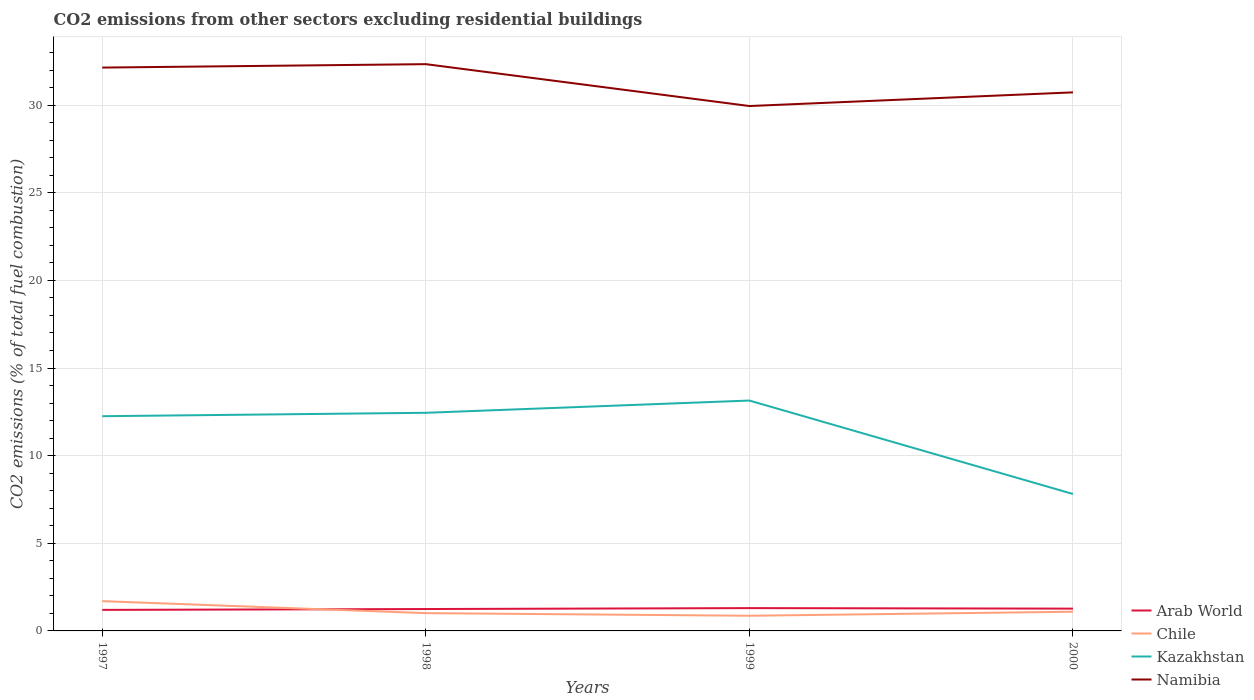Does the line corresponding to Arab World intersect with the line corresponding to Namibia?
Offer a terse response. No. Is the number of lines equal to the number of legend labels?
Ensure brevity in your answer.  Yes. Across all years, what is the maximum total CO2 emitted in Kazakhstan?
Make the answer very short. 7.81. In which year was the total CO2 emitted in Namibia maximum?
Your answer should be very brief. 1999. What is the total total CO2 emitted in Namibia in the graph?
Keep it short and to the point. 1.61. What is the difference between the highest and the second highest total CO2 emitted in Arab World?
Keep it short and to the point. 0.1. How many lines are there?
Provide a short and direct response. 4. What is the difference between two consecutive major ticks on the Y-axis?
Offer a terse response. 5. Are the values on the major ticks of Y-axis written in scientific E-notation?
Offer a terse response. No. Does the graph contain any zero values?
Give a very brief answer. No. How many legend labels are there?
Provide a succinct answer. 4. How are the legend labels stacked?
Provide a succinct answer. Vertical. What is the title of the graph?
Offer a terse response. CO2 emissions from other sectors excluding residential buildings. Does "Puerto Rico" appear as one of the legend labels in the graph?
Offer a very short reply. No. What is the label or title of the Y-axis?
Keep it short and to the point. CO2 emissions (% of total fuel combustion). What is the CO2 emissions (% of total fuel combustion) in Arab World in 1997?
Provide a short and direct response. 1.2. What is the CO2 emissions (% of total fuel combustion) of Chile in 1997?
Provide a succinct answer. 1.7. What is the CO2 emissions (% of total fuel combustion) in Kazakhstan in 1997?
Your answer should be compact. 12.25. What is the CO2 emissions (% of total fuel combustion) in Namibia in 1997?
Offer a terse response. 32.14. What is the CO2 emissions (% of total fuel combustion) of Arab World in 1998?
Keep it short and to the point. 1.25. What is the CO2 emissions (% of total fuel combustion) of Chile in 1998?
Keep it short and to the point. 1.01. What is the CO2 emissions (% of total fuel combustion) in Kazakhstan in 1998?
Provide a short and direct response. 12.45. What is the CO2 emissions (% of total fuel combustion) in Namibia in 1998?
Provide a short and direct response. 32.34. What is the CO2 emissions (% of total fuel combustion) of Arab World in 1999?
Provide a succinct answer. 1.3. What is the CO2 emissions (% of total fuel combustion) of Chile in 1999?
Your answer should be very brief. 0.87. What is the CO2 emissions (% of total fuel combustion) of Kazakhstan in 1999?
Provide a short and direct response. 13.14. What is the CO2 emissions (% of total fuel combustion) of Namibia in 1999?
Keep it short and to the point. 29.95. What is the CO2 emissions (% of total fuel combustion) in Arab World in 2000?
Keep it short and to the point. 1.27. What is the CO2 emissions (% of total fuel combustion) in Chile in 2000?
Give a very brief answer. 1.09. What is the CO2 emissions (% of total fuel combustion) of Kazakhstan in 2000?
Ensure brevity in your answer.  7.81. What is the CO2 emissions (% of total fuel combustion) of Namibia in 2000?
Ensure brevity in your answer.  30.73. Across all years, what is the maximum CO2 emissions (% of total fuel combustion) in Arab World?
Offer a very short reply. 1.3. Across all years, what is the maximum CO2 emissions (% of total fuel combustion) of Chile?
Give a very brief answer. 1.7. Across all years, what is the maximum CO2 emissions (% of total fuel combustion) in Kazakhstan?
Your answer should be very brief. 13.14. Across all years, what is the maximum CO2 emissions (% of total fuel combustion) of Namibia?
Ensure brevity in your answer.  32.34. Across all years, what is the minimum CO2 emissions (% of total fuel combustion) of Arab World?
Provide a short and direct response. 1.2. Across all years, what is the minimum CO2 emissions (% of total fuel combustion) of Chile?
Your answer should be very brief. 0.87. Across all years, what is the minimum CO2 emissions (% of total fuel combustion) of Kazakhstan?
Your answer should be very brief. 7.81. Across all years, what is the minimum CO2 emissions (% of total fuel combustion) in Namibia?
Make the answer very short. 29.95. What is the total CO2 emissions (% of total fuel combustion) in Arab World in the graph?
Offer a very short reply. 5.02. What is the total CO2 emissions (% of total fuel combustion) of Chile in the graph?
Your answer should be very brief. 4.67. What is the total CO2 emissions (% of total fuel combustion) in Kazakhstan in the graph?
Ensure brevity in your answer.  45.66. What is the total CO2 emissions (% of total fuel combustion) in Namibia in the graph?
Offer a very short reply. 125.16. What is the difference between the CO2 emissions (% of total fuel combustion) in Arab World in 1997 and that in 1998?
Make the answer very short. -0.05. What is the difference between the CO2 emissions (% of total fuel combustion) of Chile in 1997 and that in 1998?
Keep it short and to the point. 0.68. What is the difference between the CO2 emissions (% of total fuel combustion) in Kazakhstan in 1997 and that in 1998?
Provide a succinct answer. -0.19. What is the difference between the CO2 emissions (% of total fuel combustion) of Namibia in 1997 and that in 1998?
Offer a terse response. -0.2. What is the difference between the CO2 emissions (% of total fuel combustion) of Arab World in 1997 and that in 1999?
Make the answer very short. -0.1. What is the difference between the CO2 emissions (% of total fuel combustion) in Chile in 1997 and that in 1999?
Ensure brevity in your answer.  0.83. What is the difference between the CO2 emissions (% of total fuel combustion) in Kazakhstan in 1997 and that in 1999?
Offer a terse response. -0.89. What is the difference between the CO2 emissions (% of total fuel combustion) of Namibia in 1997 and that in 1999?
Provide a succinct answer. 2.19. What is the difference between the CO2 emissions (% of total fuel combustion) of Arab World in 1997 and that in 2000?
Your answer should be very brief. -0.07. What is the difference between the CO2 emissions (% of total fuel combustion) in Chile in 1997 and that in 2000?
Keep it short and to the point. 0.6. What is the difference between the CO2 emissions (% of total fuel combustion) of Kazakhstan in 1997 and that in 2000?
Keep it short and to the point. 4.44. What is the difference between the CO2 emissions (% of total fuel combustion) in Namibia in 1997 and that in 2000?
Offer a terse response. 1.41. What is the difference between the CO2 emissions (% of total fuel combustion) of Arab World in 1998 and that in 1999?
Your answer should be compact. -0.05. What is the difference between the CO2 emissions (% of total fuel combustion) of Chile in 1998 and that in 1999?
Your answer should be compact. 0.15. What is the difference between the CO2 emissions (% of total fuel combustion) of Kazakhstan in 1998 and that in 1999?
Offer a terse response. -0.7. What is the difference between the CO2 emissions (% of total fuel combustion) in Namibia in 1998 and that in 1999?
Offer a terse response. 2.39. What is the difference between the CO2 emissions (% of total fuel combustion) in Arab World in 1998 and that in 2000?
Offer a terse response. -0.02. What is the difference between the CO2 emissions (% of total fuel combustion) in Chile in 1998 and that in 2000?
Give a very brief answer. -0.08. What is the difference between the CO2 emissions (% of total fuel combustion) of Kazakhstan in 1998 and that in 2000?
Provide a short and direct response. 4.63. What is the difference between the CO2 emissions (% of total fuel combustion) of Namibia in 1998 and that in 2000?
Keep it short and to the point. 1.61. What is the difference between the CO2 emissions (% of total fuel combustion) of Arab World in 1999 and that in 2000?
Give a very brief answer. 0.03. What is the difference between the CO2 emissions (% of total fuel combustion) in Chile in 1999 and that in 2000?
Your answer should be very brief. -0.23. What is the difference between the CO2 emissions (% of total fuel combustion) in Kazakhstan in 1999 and that in 2000?
Make the answer very short. 5.33. What is the difference between the CO2 emissions (% of total fuel combustion) in Namibia in 1999 and that in 2000?
Give a very brief answer. -0.78. What is the difference between the CO2 emissions (% of total fuel combustion) of Arab World in 1997 and the CO2 emissions (% of total fuel combustion) of Chile in 1998?
Provide a succinct answer. 0.19. What is the difference between the CO2 emissions (% of total fuel combustion) in Arab World in 1997 and the CO2 emissions (% of total fuel combustion) in Kazakhstan in 1998?
Give a very brief answer. -11.25. What is the difference between the CO2 emissions (% of total fuel combustion) in Arab World in 1997 and the CO2 emissions (% of total fuel combustion) in Namibia in 1998?
Your answer should be compact. -31.14. What is the difference between the CO2 emissions (% of total fuel combustion) in Chile in 1997 and the CO2 emissions (% of total fuel combustion) in Kazakhstan in 1998?
Your answer should be very brief. -10.75. What is the difference between the CO2 emissions (% of total fuel combustion) in Chile in 1997 and the CO2 emissions (% of total fuel combustion) in Namibia in 1998?
Provide a succinct answer. -30.64. What is the difference between the CO2 emissions (% of total fuel combustion) in Kazakhstan in 1997 and the CO2 emissions (% of total fuel combustion) in Namibia in 1998?
Keep it short and to the point. -20.09. What is the difference between the CO2 emissions (% of total fuel combustion) of Arab World in 1997 and the CO2 emissions (% of total fuel combustion) of Chile in 1999?
Provide a short and direct response. 0.33. What is the difference between the CO2 emissions (% of total fuel combustion) in Arab World in 1997 and the CO2 emissions (% of total fuel combustion) in Kazakhstan in 1999?
Offer a terse response. -11.94. What is the difference between the CO2 emissions (% of total fuel combustion) of Arab World in 1997 and the CO2 emissions (% of total fuel combustion) of Namibia in 1999?
Provide a succinct answer. -28.75. What is the difference between the CO2 emissions (% of total fuel combustion) in Chile in 1997 and the CO2 emissions (% of total fuel combustion) in Kazakhstan in 1999?
Offer a very short reply. -11.45. What is the difference between the CO2 emissions (% of total fuel combustion) of Chile in 1997 and the CO2 emissions (% of total fuel combustion) of Namibia in 1999?
Provide a succinct answer. -28.25. What is the difference between the CO2 emissions (% of total fuel combustion) in Kazakhstan in 1997 and the CO2 emissions (% of total fuel combustion) in Namibia in 1999?
Give a very brief answer. -17.7. What is the difference between the CO2 emissions (% of total fuel combustion) of Arab World in 1997 and the CO2 emissions (% of total fuel combustion) of Chile in 2000?
Ensure brevity in your answer.  0.1. What is the difference between the CO2 emissions (% of total fuel combustion) of Arab World in 1997 and the CO2 emissions (% of total fuel combustion) of Kazakhstan in 2000?
Your response must be concise. -6.61. What is the difference between the CO2 emissions (% of total fuel combustion) of Arab World in 1997 and the CO2 emissions (% of total fuel combustion) of Namibia in 2000?
Ensure brevity in your answer.  -29.53. What is the difference between the CO2 emissions (% of total fuel combustion) in Chile in 1997 and the CO2 emissions (% of total fuel combustion) in Kazakhstan in 2000?
Offer a very short reply. -6.12. What is the difference between the CO2 emissions (% of total fuel combustion) of Chile in 1997 and the CO2 emissions (% of total fuel combustion) of Namibia in 2000?
Provide a short and direct response. -29.03. What is the difference between the CO2 emissions (% of total fuel combustion) of Kazakhstan in 1997 and the CO2 emissions (% of total fuel combustion) of Namibia in 2000?
Offer a terse response. -18.48. What is the difference between the CO2 emissions (% of total fuel combustion) of Arab World in 1998 and the CO2 emissions (% of total fuel combustion) of Chile in 1999?
Provide a succinct answer. 0.38. What is the difference between the CO2 emissions (% of total fuel combustion) in Arab World in 1998 and the CO2 emissions (% of total fuel combustion) in Kazakhstan in 1999?
Provide a succinct answer. -11.9. What is the difference between the CO2 emissions (% of total fuel combustion) of Arab World in 1998 and the CO2 emissions (% of total fuel combustion) of Namibia in 1999?
Ensure brevity in your answer.  -28.7. What is the difference between the CO2 emissions (% of total fuel combustion) of Chile in 1998 and the CO2 emissions (% of total fuel combustion) of Kazakhstan in 1999?
Your response must be concise. -12.13. What is the difference between the CO2 emissions (% of total fuel combustion) in Chile in 1998 and the CO2 emissions (% of total fuel combustion) in Namibia in 1999?
Ensure brevity in your answer.  -28.93. What is the difference between the CO2 emissions (% of total fuel combustion) of Kazakhstan in 1998 and the CO2 emissions (% of total fuel combustion) of Namibia in 1999?
Offer a very short reply. -17.5. What is the difference between the CO2 emissions (% of total fuel combustion) of Arab World in 1998 and the CO2 emissions (% of total fuel combustion) of Chile in 2000?
Give a very brief answer. 0.15. What is the difference between the CO2 emissions (% of total fuel combustion) of Arab World in 1998 and the CO2 emissions (% of total fuel combustion) of Kazakhstan in 2000?
Offer a terse response. -6.57. What is the difference between the CO2 emissions (% of total fuel combustion) in Arab World in 1998 and the CO2 emissions (% of total fuel combustion) in Namibia in 2000?
Keep it short and to the point. -29.48. What is the difference between the CO2 emissions (% of total fuel combustion) in Chile in 1998 and the CO2 emissions (% of total fuel combustion) in Kazakhstan in 2000?
Ensure brevity in your answer.  -6.8. What is the difference between the CO2 emissions (% of total fuel combustion) of Chile in 1998 and the CO2 emissions (% of total fuel combustion) of Namibia in 2000?
Make the answer very short. -29.71. What is the difference between the CO2 emissions (% of total fuel combustion) in Kazakhstan in 1998 and the CO2 emissions (% of total fuel combustion) in Namibia in 2000?
Keep it short and to the point. -18.28. What is the difference between the CO2 emissions (% of total fuel combustion) of Arab World in 1999 and the CO2 emissions (% of total fuel combustion) of Chile in 2000?
Provide a short and direct response. 0.21. What is the difference between the CO2 emissions (% of total fuel combustion) in Arab World in 1999 and the CO2 emissions (% of total fuel combustion) in Kazakhstan in 2000?
Ensure brevity in your answer.  -6.51. What is the difference between the CO2 emissions (% of total fuel combustion) of Arab World in 1999 and the CO2 emissions (% of total fuel combustion) of Namibia in 2000?
Your response must be concise. -29.43. What is the difference between the CO2 emissions (% of total fuel combustion) of Chile in 1999 and the CO2 emissions (% of total fuel combustion) of Kazakhstan in 2000?
Your answer should be very brief. -6.95. What is the difference between the CO2 emissions (% of total fuel combustion) of Chile in 1999 and the CO2 emissions (% of total fuel combustion) of Namibia in 2000?
Make the answer very short. -29.86. What is the difference between the CO2 emissions (% of total fuel combustion) in Kazakhstan in 1999 and the CO2 emissions (% of total fuel combustion) in Namibia in 2000?
Give a very brief answer. -17.58. What is the average CO2 emissions (% of total fuel combustion) in Arab World per year?
Make the answer very short. 1.26. What is the average CO2 emissions (% of total fuel combustion) of Chile per year?
Make the answer very short. 1.17. What is the average CO2 emissions (% of total fuel combustion) of Kazakhstan per year?
Your response must be concise. 11.41. What is the average CO2 emissions (% of total fuel combustion) of Namibia per year?
Make the answer very short. 31.29. In the year 1997, what is the difference between the CO2 emissions (% of total fuel combustion) of Arab World and CO2 emissions (% of total fuel combustion) of Chile?
Your answer should be very brief. -0.5. In the year 1997, what is the difference between the CO2 emissions (% of total fuel combustion) in Arab World and CO2 emissions (% of total fuel combustion) in Kazakhstan?
Your response must be concise. -11.05. In the year 1997, what is the difference between the CO2 emissions (% of total fuel combustion) of Arab World and CO2 emissions (% of total fuel combustion) of Namibia?
Offer a very short reply. -30.94. In the year 1997, what is the difference between the CO2 emissions (% of total fuel combustion) in Chile and CO2 emissions (% of total fuel combustion) in Kazakhstan?
Your answer should be very brief. -10.55. In the year 1997, what is the difference between the CO2 emissions (% of total fuel combustion) in Chile and CO2 emissions (% of total fuel combustion) in Namibia?
Give a very brief answer. -30.44. In the year 1997, what is the difference between the CO2 emissions (% of total fuel combustion) in Kazakhstan and CO2 emissions (% of total fuel combustion) in Namibia?
Provide a succinct answer. -19.89. In the year 1998, what is the difference between the CO2 emissions (% of total fuel combustion) of Arab World and CO2 emissions (% of total fuel combustion) of Chile?
Keep it short and to the point. 0.23. In the year 1998, what is the difference between the CO2 emissions (% of total fuel combustion) in Arab World and CO2 emissions (% of total fuel combustion) in Kazakhstan?
Provide a succinct answer. -11.2. In the year 1998, what is the difference between the CO2 emissions (% of total fuel combustion) of Arab World and CO2 emissions (% of total fuel combustion) of Namibia?
Your response must be concise. -31.09. In the year 1998, what is the difference between the CO2 emissions (% of total fuel combustion) of Chile and CO2 emissions (% of total fuel combustion) of Kazakhstan?
Your response must be concise. -11.43. In the year 1998, what is the difference between the CO2 emissions (% of total fuel combustion) in Chile and CO2 emissions (% of total fuel combustion) in Namibia?
Your answer should be very brief. -31.32. In the year 1998, what is the difference between the CO2 emissions (% of total fuel combustion) in Kazakhstan and CO2 emissions (% of total fuel combustion) in Namibia?
Provide a succinct answer. -19.89. In the year 1999, what is the difference between the CO2 emissions (% of total fuel combustion) of Arab World and CO2 emissions (% of total fuel combustion) of Chile?
Make the answer very short. 0.44. In the year 1999, what is the difference between the CO2 emissions (% of total fuel combustion) of Arab World and CO2 emissions (% of total fuel combustion) of Kazakhstan?
Ensure brevity in your answer.  -11.84. In the year 1999, what is the difference between the CO2 emissions (% of total fuel combustion) of Arab World and CO2 emissions (% of total fuel combustion) of Namibia?
Offer a very short reply. -28.65. In the year 1999, what is the difference between the CO2 emissions (% of total fuel combustion) of Chile and CO2 emissions (% of total fuel combustion) of Kazakhstan?
Give a very brief answer. -12.28. In the year 1999, what is the difference between the CO2 emissions (% of total fuel combustion) in Chile and CO2 emissions (% of total fuel combustion) in Namibia?
Ensure brevity in your answer.  -29.08. In the year 1999, what is the difference between the CO2 emissions (% of total fuel combustion) of Kazakhstan and CO2 emissions (% of total fuel combustion) of Namibia?
Keep it short and to the point. -16.8. In the year 2000, what is the difference between the CO2 emissions (% of total fuel combustion) of Arab World and CO2 emissions (% of total fuel combustion) of Chile?
Your response must be concise. 0.18. In the year 2000, what is the difference between the CO2 emissions (% of total fuel combustion) of Arab World and CO2 emissions (% of total fuel combustion) of Kazakhstan?
Offer a very short reply. -6.54. In the year 2000, what is the difference between the CO2 emissions (% of total fuel combustion) of Arab World and CO2 emissions (% of total fuel combustion) of Namibia?
Provide a short and direct response. -29.46. In the year 2000, what is the difference between the CO2 emissions (% of total fuel combustion) in Chile and CO2 emissions (% of total fuel combustion) in Kazakhstan?
Offer a terse response. -6.72. In the year 2000, what is the difference between the CO2 emissions (% of total fuel combustion) in Chile and CO2 emissions (% of total fuel combustion) in Namibia?
Provide a succinct answer. -29.63. In the year 2000, what is the difference between the CO2 emissions (% of total fuel combustion) in Kazakhstan and CO2 emissions (% of total fuel combustion) in Namibia?
Your answer should be compact. -22.91. What is the ratio of the CO2 emissions (% of total fuel combustion) in Arab World in 1997 to that in 1998?
Give a very brief answer. 0.96. What is the ratio of the CO2 emissions (% of total fuel combustion) in Chile in 1997 to that in 1998?
Ensure brevity in your answer.  1.67. What is the ratio of the CO2 emissions (% of total fuel combustion) in Kazakhstan in 1997 to that in 1998?
Give a very brief answer. 0.98. What is the ratio of the CO2 emissions (% of total fuel combustion) in Arab World in 1997 to that in 1999?
Keep it short and to the point. 0.92. What is the ratio of the CO2 emissions (% of total fuel combustion) of Chile in 1997 to that in 1999?
Provide a succinct answer. 1.96. What is the ratio of the CO2 emissions (% of total fuel combustion) of Kazakhstan in 1997 to that in 1999?
Give a very brief answer. 0.93. What is the ratio of the CO2 emissions (% of total fuel combustion) in Namibia in 1997 to that in 1999?
Give a very brief answer. 1.07. What is the ratio of the CO2 emissions (% of total fuel combustion) of Arab World in 1997 to that in 2000?
Offer a very short reply. 0.94. What is the ratio of the CO2 emissions (% of total fuel combustion) of Chile in 1997 to that in 2000?
Provide a short and direct response. 1.55. What is the ratio of the CO2 emissions (% of total fuel combustion) of Kazakhstan in 1997 to that in 2000?
Your response must be concise. 1.57. What is the ratio of the CO2 emissions (% of total fuel combustion) in Namibia in 1997 to that in 2000?
Your answer should be very brief. 1.05. What is the ratio of the CO2 emissions (% of total fuel combustion) of Arab World in 1998 to that in 1999?
Offer a very short reply. 0.96. What is the ratio of the CO2 emissions (% of total fuel combustion) of Chile in 1998 to that in 1999?
Give a very brief answer. 1.17. What is the ratio of the CO2 emissions (% of total fuel combustion) in Kazakhstan in 1998 to that in 1999?
Provide a short and direct response. 0.95. What is the ratio of the CO2 emissions (% of total fuel combustion) of Namibia in 1998 to that in 1999?
Offer a terse response. 1.08. What is the ratio of the CO2 emissions (% of total fuel combustion) in Arab World in 1998 to that in 2000?
Your answer should be very brief. 0.98. What is the ratio of the CO2 emissions (% of total fuel combustion) in Chile in 1998 to that in 2000?
Give a very brief answer. 0.93. What is the ratio of the CO2 emissions (% of total fuel combustion) of Kazakhstan in 1998 to that in 2000?
Your answer should be compact. 1.59. What is the ratio of the CO2 emissions (% of total fuel combustion) in Namibia in 1998 to that in 2000?
Keep it short and to the point. 1.05. What is the ratio of the CO2 emissions (% of total fuel combustion) of Arab World in 1999 to that in 2000?
Ensure brevity in your answer.  1.02. What is the ratio of the CO2 emissions (% of total fuel combustion) in Chile in 1999 to that in 2000?
Offer a very short reply. 0.79. What is the ratio of the CO2 emissions (% of total fuel combustion) in Kazakhstan in 1999 to that in 2000?
Offer a terse response. 1.68. What is the ratio of the CO2 emissions (% of total fuel combustion) in Namibia in 1999 to that in 2000?
Your response must be concise. 0.97. What is the difference between the highest and the second highest CO2 emissions (% of total fuel combustion) of Arab World?
Your response must be concise. 0.03. What is the difference between the highest and the second highest CO2 emissions (% of total fuel combustion) in Chile?
Give a very brief answer. 0.6. What is the difference between the highest and the second highest CO2 emissions (% of total fuel combustion) in Kazakhstan?
Make the answer very short. 0.7. What is the difference between the highest and the second highest CO2 emissions (% of total fuel combustion) of Namibia?
Give a very brief answer. 0.2. What is the difference between the highest and the lowest CO2 emissions (% of total fuel combustion) of Arab World?
Provide a succinct answer. 0.1. What is the difference between the highest and the lowest CO2 emissions (% of total fuel combustion) of Chile?
Provide a short and direct response. 0.83. What is the difference between the highest and the lowest CO2 emissions (% of total fuel combustion) in Kazakhstan?
Your answer should be compact. 5.33. What is the difference between the highest and the lowest CO2 emissions (% of total fuel combustion) of Namibia?
Offer a very short reply. 2.39. 